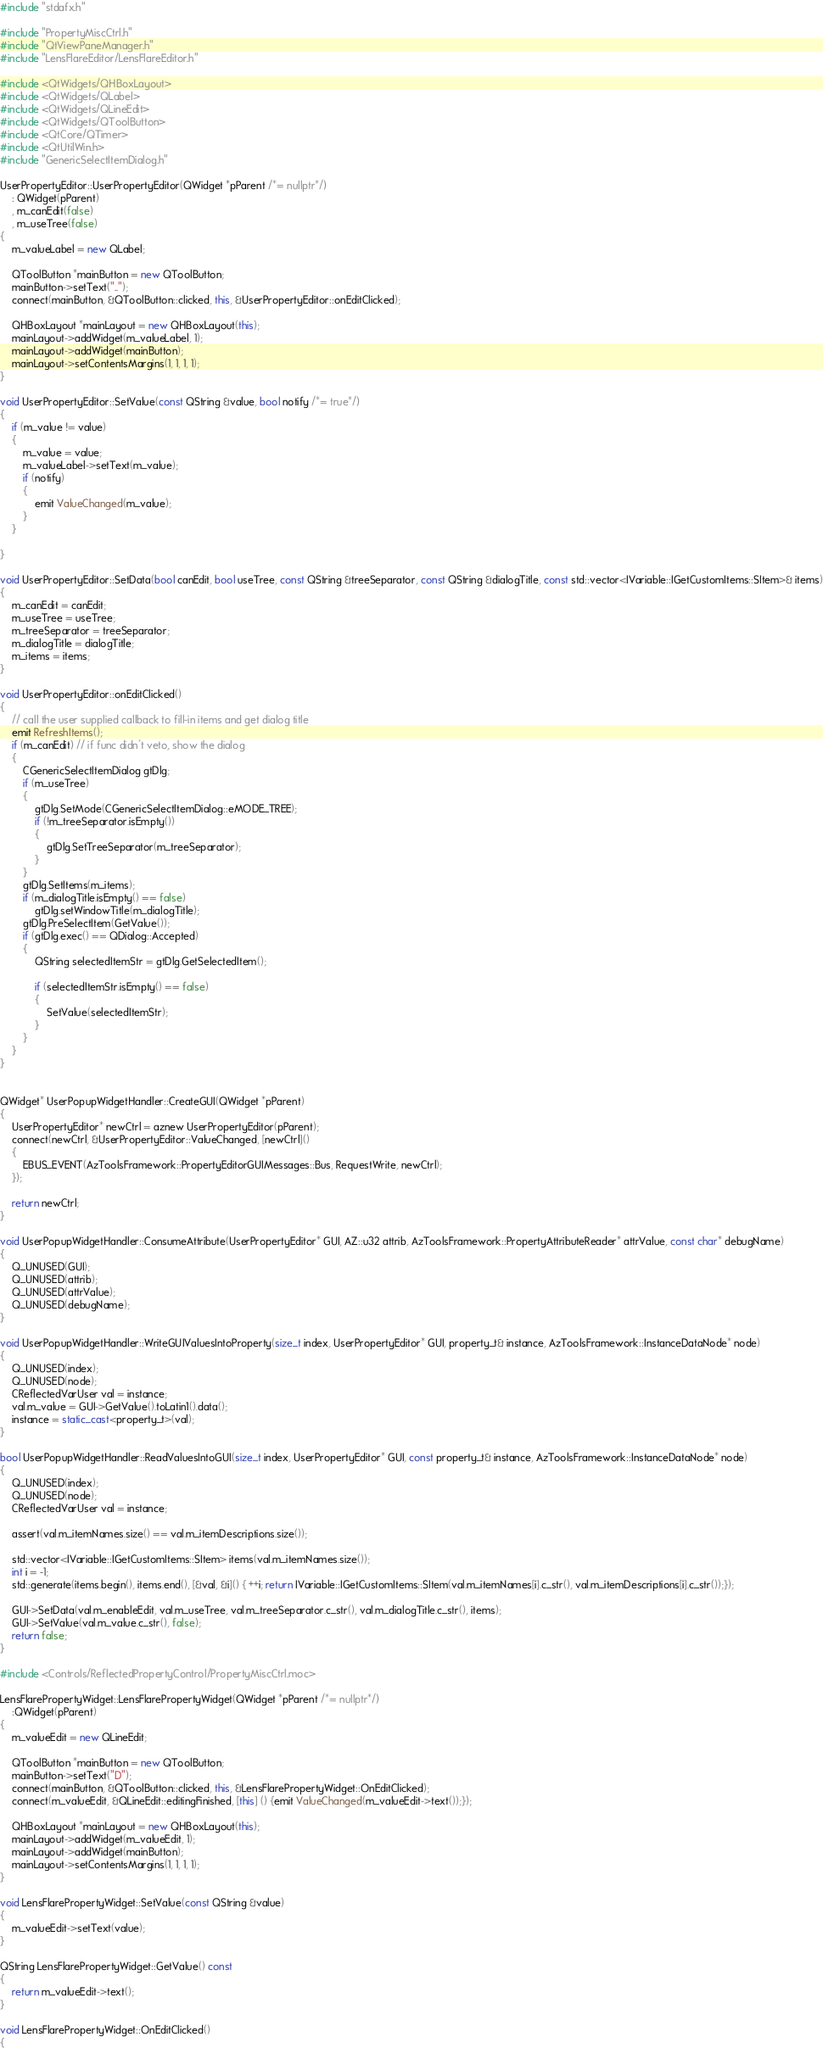<code> <loc_0><loc_0><loc_500><loc_500><_C++_>#include "stdafx.h"

#include "PropertyMiscCtrl.h"
#include "QtViewPaneManager.h"
#include "LensFlareEditor/LensFlareEditor.h"

#include <QtWidgets/QHBoxLayout>
#include <QtWidgets/QLabel>
#include <QtWidgets/QLineEdit>
#include <QtWidgets/QToolButton>
#include <QtCore/QTimer>
#include <QtUtilWin.h>
#include "GenericSelectItemDialog.h"

UserPropertyEditor::UserPropertyEditor(QWidget *pParent /*= nullptr*/)
    : QWidget(pParent)
    , m_canEdit(false)
    , m_useTree(false)
{
    m_valueLabel = new QLabel;

    QToolButton *mainButton = new QToolButton;
    mainButton->setText("..");
    connect(mainButton, &QToolButton::clicked, this, &UserPropertyEditor::onEditClicked);

    QHBoxLayout *mainLayout = new QHBoxLayout(this);
    mainLayout->addWidget(m_valueLabel, 1);
    mainLayout->addWidget(mainButton);
    mainLayout->setContentsMargins(1, 1, 1, 1);
}

void UserPropertyEditor::SetValue(const QString &value, bool notify /*= true*/)
{
    if (m_value != value)
    {
        m_value = value;
        m_valueLabel->setText(m_value);
        if (notify)
        {
            emit ValueChanged(m_value);
        }
    }

}

void UserPropertyEditor::SetData(bool canEdit, bool useTree, const QString &treeSeparator, const QString &dialogTitle, const std::vector<IVariable::IGetCustomItems::SItem>& items)
{
    m_canEdit = canEdit;
    m_useTree = useTree;
    m_treeSeparator = treeSeparator;
    m_dialogTitle = dialogTitle;
    m_items = items;
}

void UserPropertyEditor::onEditClicked()
{
    // call the user supplied callback to fill-in items and get dialog title
    emit RefreshItems();
    if (m_canEdit) // if func didn't veto, show the dialog
    {
        CGenericSelectItemDialog gtDlg;
        if (m_useTree)
        {
            gtDlg.SetMode(CGenericSelectItemDialog::eMODE_TREE);
            if (!m_treeSeparator.isEmpty())
            {
                gtDlg.SetTreeSeparator(m_treeSeparator);
            }
        }
        gtDlg.SetItems(m_items);
        if (m_dialogTitle.isEmpty() == false)
            gtDlg.setWindowTitle(m_dialogTitle);
        gtDlg.PreSelectItem(GetValue());
        if (gtDlg.exec() == QDialog::Accepted)
        {
            QString selectedItemStr = gtDlg.GetSelectedItem();

            if (selectedItemStr.isEmpty() == false)
            {
                SetValue(selectedItemStr);
            }
        }
    }
}


QWidget* UserPopupWidgetHandler::CreateGUI(QWidget *pParent)
{
    UserPropertyEditor* newCtrl = aznew UserPropertyEditor(pParent);
    connect(newCtrl, &UserPropertyEditor::ValueChanged, [newCtrl]()
    {
        EBUS_EVENT(AzToolsFramework::PropertyEditorGUIMessages::Bus, RequestWrite, newCtrl);
    });

    return newCtrl;
}

void UserPopupWidgetHandler::ConsumeAttribute(UserPropertyEditor* GUI, AZ::u32 attrib, AzToolsFramework::PropertyAttributeReader* attrValue, const char* debugName)
{
    Q_UNUSED(GUI);
    Q_UNUSED(attrib);
    Q_UNUSED(attrValue);
    Q_UNUSED(debugName);
}

void UserPopupWidgetHandler::WriteGUIValuesIntoProperty(size_t index, UserPropertyEditor* GUI, property_t& instance, AzToolsFramework::InstanceDataNode* node)
{
    Q_UNUSED(index);
    Q_UNUSED(node);
    CReflectedVarUser val = instance;
    val.m_value = GUI->GetValue().toLatin1().data();
    instance = static_cast<property_t>(val);
}

bool UserPopupWidgetHandler::ReadValuesIntoGUI(size_t index, UserPropertyEditor* GUI, const property_t& instance, AzToolsFramework::InstanceDataNode* node)
{
    Q_UNUSED(index);
    Q_UNUSED(node);
    CReflectedVarUser val = instance;

    assert(val.m_itemNames.size() == val.m_itemDescriptions.size());

    std::vector<IVariable::IGetCustomItems::SItem> items(val.m_itemNames.size());
    int i = -1;
    std::generate(items.begin(), items.end(), [&val, &i]() { ++i; return IVariable::IGetCustomItems::SItem(val.m_itemNames[i].c_str(), val.m_itemDescriptions[i].c_str());});

    GUI->SetData(val.m_enableEdit, val.m_useTree, val.m_treeSeparator.c_str(), val.m_dialogTitle.c_str(), items);
    GUI->SetValue(val.m_value.c_str(), false);
    return false;
}

#include <Controls/ReflectedPropertyControl/PropertyMiscCtrl.moc>

LensFlarePropertyWidget::LensFlarePropertyWidget(QWidget *pParent /*= nullptr*/)
    :QWidget(pParent)
{
    m_valueEdit = new QLineEdit;

    QToolButton *mainButton = new QToolButton;
    mainButton->setText("D");
    connect(mainButton, &QToolButton::clicked, this, &LensFlarePropertyWidget::OnEditClicked);
    connect(m_valueEdit, &QLineEdit::editingFinished, [this] () {emit ValueChanged(m_valueEdit->text());});

    QHBoxLayout *mainLayout = new QHBoxLayout(this);
    mainLayout->addWidget(m_valueEdit, 1);
    mainLayout->addWidget(mainButton);
    mainLayout->setContentsMargins(1, 1, 1, 1);
}

void LensFlarePropertyWidget::SetValue(const QString &value)
{
    m_valueEdit->setText(value);
}

QString LensFlarePropertyWidget::GetValue() const
{ 
    return m_valueEdit->text();
}

void LensFlarePropertyWidget::OnEditClicked()
{</code> 